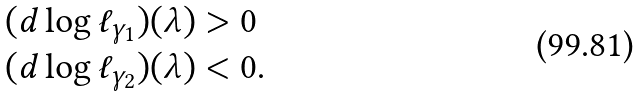<formula> <loc_0><loc_0><loc_500><loc_500>( d \log \ell _ { \gamma _ { 1 } } ) ( \lambda ) & > 0 \\ ( d \log \ell _ { \gamma _ { 2 } } ) ( \lambda ) & < 0 .</formula> 